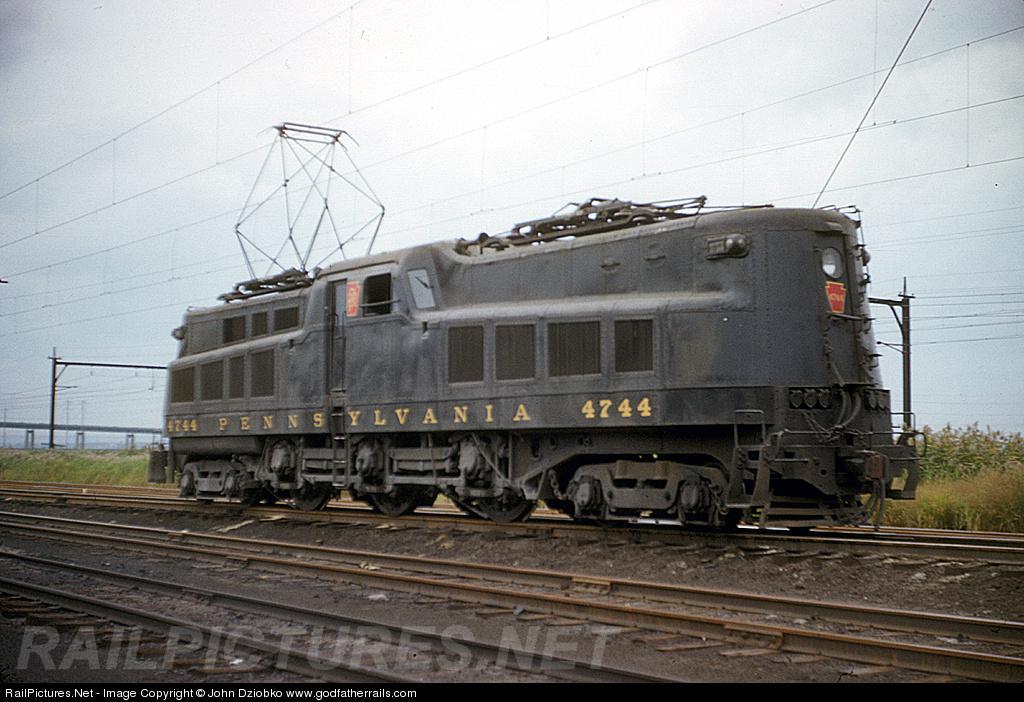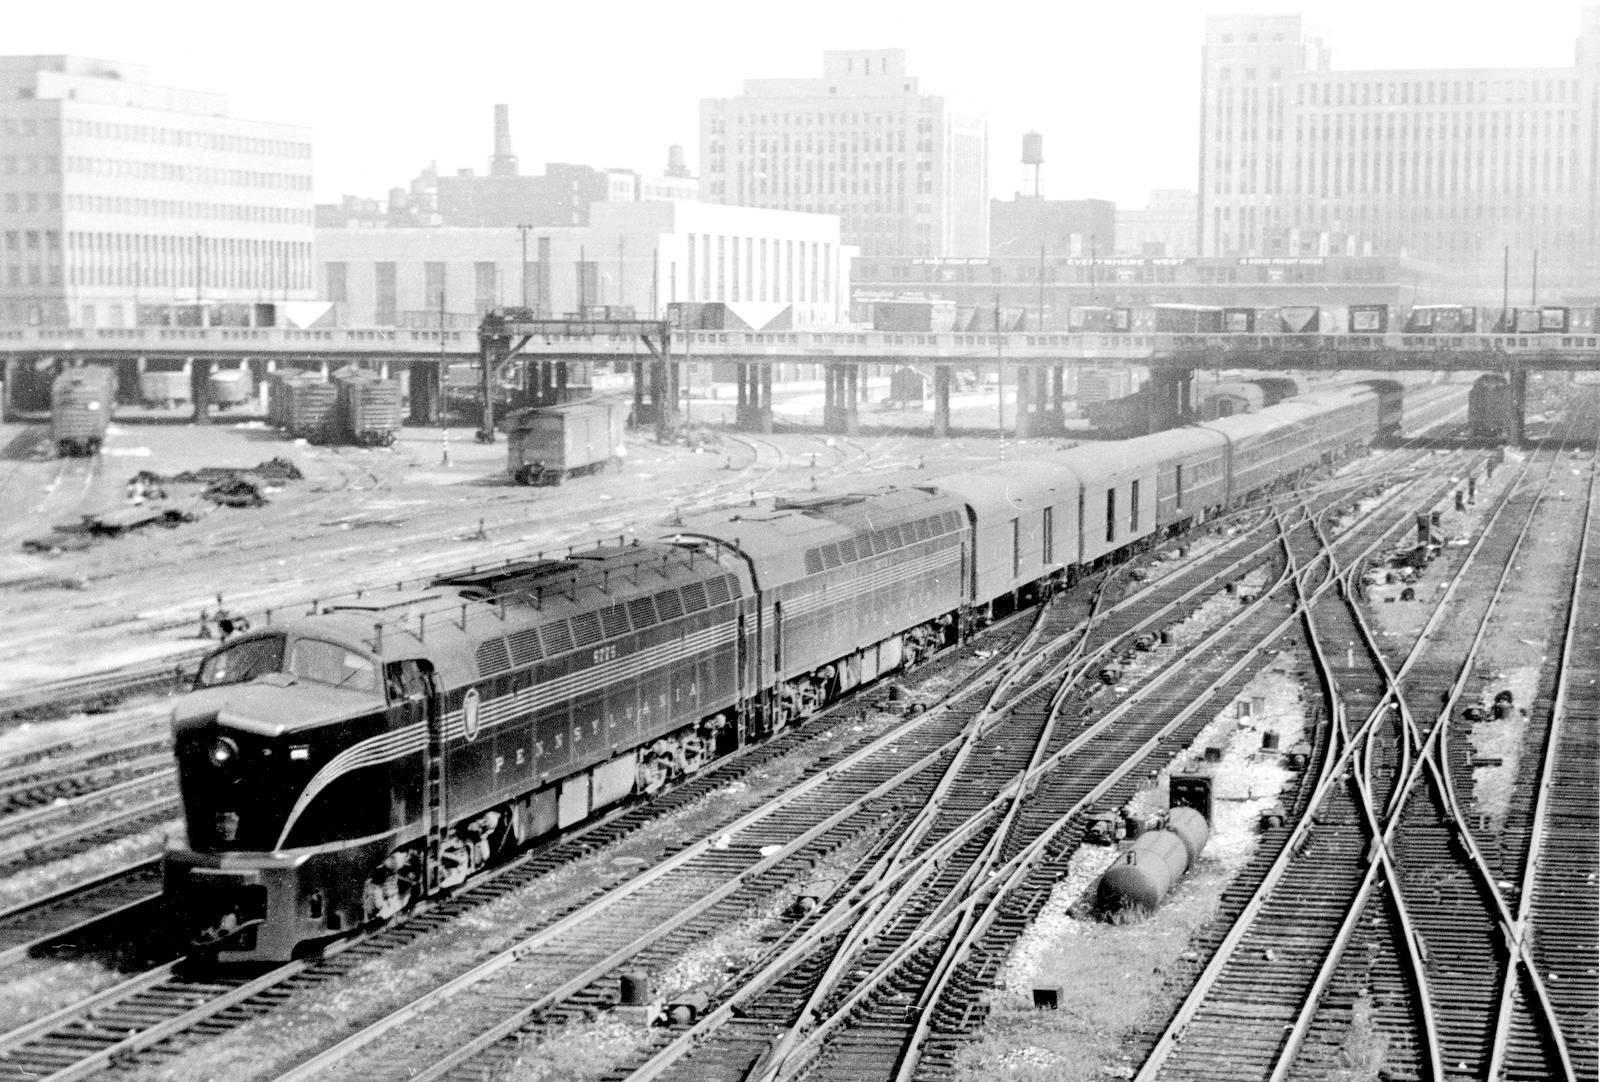The first image is the image on the left, the second image is the image on the right. Evaluate the accuracy of this statement regarding the images: "All trains are heading to the right.". Is it true? Answer yes or no. No. The first image is the image on the left, the second image is the image on the right. Given the left and right images, does the statement "An image shows a train with a rounded front and a stripe that curves up from the bottom of the front to run along the side, and geometric 3D frames are above the train." hold true? Answer yes or no. No. 